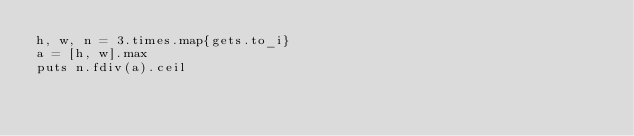Convert code to text. <code><loc_0><loc_0><loc_500><loc_500><_Ruby_>h, w, n = 3.times.map{gets.to_i}
a = [h, w].max
puts n.fdiv(a).ceil</code> 